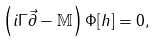<formula> <loc_0><loc_0><loc_500><loc_500>\left ( i \Gamma \vec { \partial } - \mathbb { M } \right ) \Phi [ h ] = 0 ,</formula> 